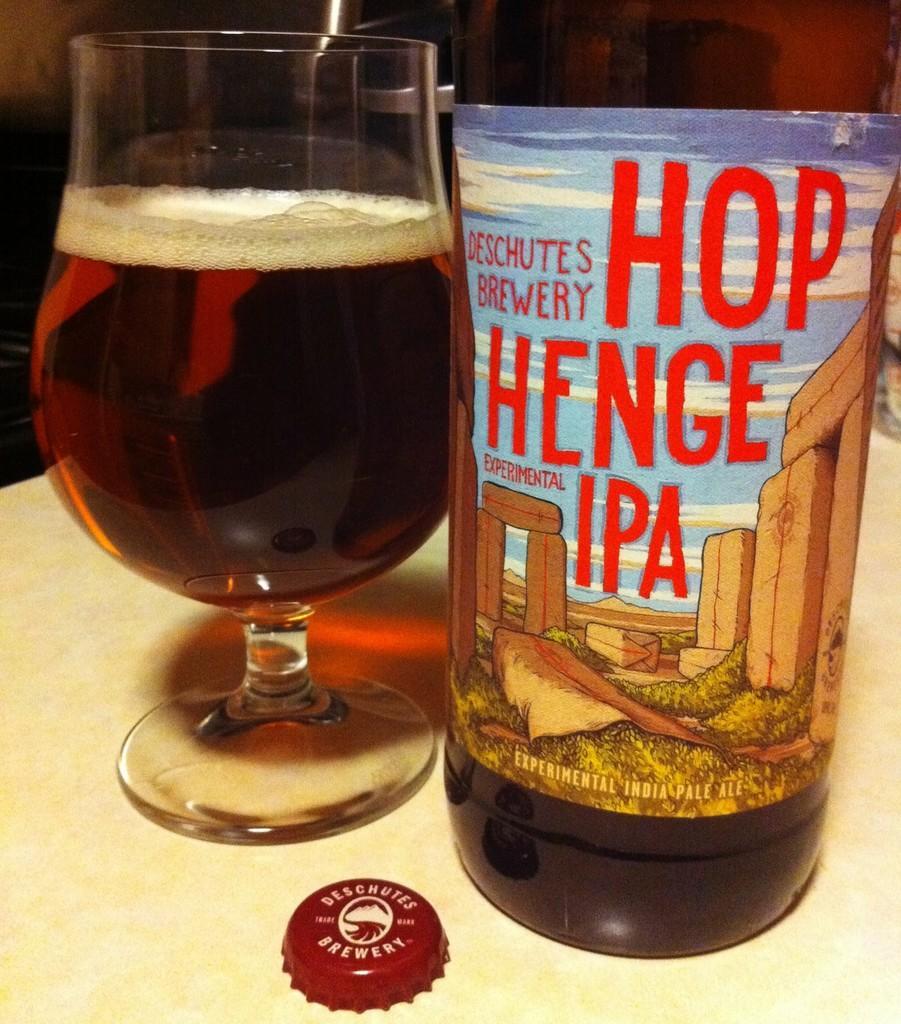How would you summarize this image in a sentence or two? In this image there is a bottle and wine glass with drink kept on a table. 